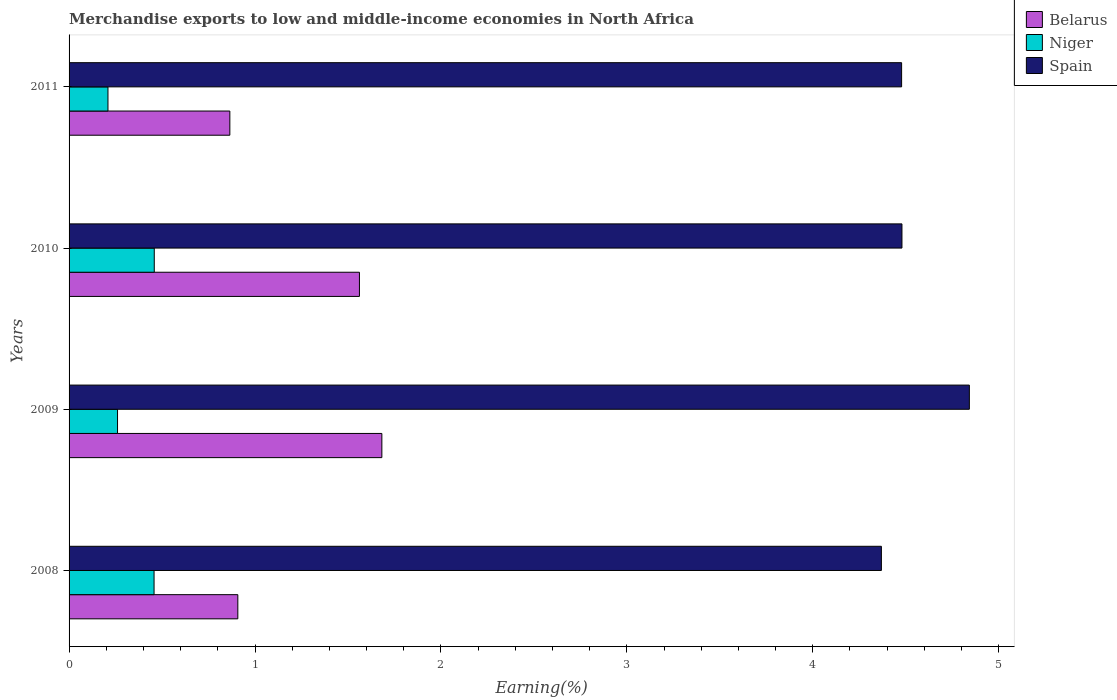How many different coloured bars are there?
Give a very brief answer. 3. How many groups of bars are there?
Offer a terse response. 4. Are the number of bars per tick equal to the number of legend labels?
Ensure brevity in your answer.  Yes. How many bars are there on the 4th tick from the top?
Offer a terse response. 3. How many bars are there on the 2nd tick from the bottom?
Offer a terse response. 3. What is the label of the 3rd group of bars from the top?
Make the answer very short. 2009. In how many cases, is the number of bars for a given year not equal to the number of legend labels?
Offer a terse response. 0. What is the percentage of amount earned from merchandise exports in Belarus in 2010?
Offer a very short reply. 1.56. Across all years, what is the maximum percentage of amount earned from merchandise exports in Niger?
Offer a very short reply. 0.46. Across all years, what is the minimum percentage of amount earned from merchandise exports in Belarus?
Keep it short and to the point. 0.86. In which year was the percentage of amount earned from merchandise exports in Belarus minimum?
Your answer should be compact. 2011. What is the total percentage of amount earned from merchandise exports in Spain in the graph?
Offer a terse response. 18.17. What is the difference between the percentage of amount earned from merchandise exports in Belarus in 2009 and that in 2011?
Make the answer very short. 0.82. What is the difference between the percentage of amount earned from merchandise exports in Spain in 2010 and the percentage of amount earned from merchandise exports in Belarus in 2008?
Offer a very short reply. 3.57. What is the average percentage of amount earned from merchandise exports in Belarus per year?
Make the answer very short. 1.25. In the year 2011, what is the difference between the percentage of amount earned from merchandise exports in Belarus and percentage of amount earned from merchandise exports in Spain?
Ensure brevity in your answer.  -3.61. In how many years, is the percentage of amount earned from merchandise exports in Belarus greater than 1.4 %?
Your answer should be very brief. 2. What is the ratio of the percentage of amount earned from merchandise exports in Niger in 2009 to that in 2010?
Keep it short and to the point. 0.57. What is the difference between the highest and the second highest percentage of amount earned from merchandise exports in Belarus?
Offer a terse response. 0.12. What is the difference between the highest and the lowest percentage of amount earned from merchandise exports in Belarus?
Keep it short and to the point. 0.82. In how many years, is the percentage of amount earned from merchandise exports in Spain greater than the average percentage of amount earned from merchandise exports in Spain taken over all years?
Your answer should be very brief. 1. What does the 1st bar from the bottom in 2009 represents?
Provide a succinct answer. Belarus. How many bars are there?
Provide a short and direct response. 12. What is the difference between two consecutive major ticks on the X-axis?
Ensure brevity in your answer.  1. Are the values on the major ticks of X-axis written in scientific E-notation?
Provide a short and direct response. No. Does the graph contain any zero values?
Your answer should be compact. No. Where does the legend appear in the graph?
Your answer should be compact. Top right. How are the legend labels stacked?
Your answer should be very brief. Vertical. What is the title of the graph?
Keep it short and to the point. Merchandise exports to low and middle-income economies in North Africa. What is the label or title of the X-axis?
Provide a short and direct response. Earning(%). What is the label or title of the Y-axis?
Provide a succinct answer. Years. What is the Earning(%) in Belarus in 2008?
Your answer should be very brief. 0.91. What is the Earning(%) in Niger in 2008?
Provide a short and direct response. 0.46. What is the Earning(%) in Spain in 2008?
Offer a terse response. 4.37. What is the Earning(%) in Belarus in 2009?
Offer a terse response. 1.68. What is the Earning(%) of Niger in 2009?
Provide a succinct answer. 0.26. What is the Earning(%) of Spain in 2009?
Give a very brief answer. 4.84. What is the Earning(%) in Belarus in 2010?
Ensure brevity in your answer.  1.56. What is the Earning(%) in Niger in 2010?
Your answer should be compact. 0.46. What is the Earning(%) of Spain in 2010?
Your answer should be very brief. 4.48. What is the Earning(%) of Belarus in 2011?
Make the answer very short. 0.86. What is the Earning(%) in Niger in 2011?
Provide a succinct answer. 0.21. What is the Earning(%) in Spain in 2011?
Your response must be concise. 4.48. Across all years, what is the maximum Earning(%) of Belarus?
Give a very brief answer. 1.68. Across all years, what is the maximum Earning(%) in Niger?
Your answer should be compact. 0.46. Across all years, what is the maximum Earning(%) of Spain?
Give a very brief answer. 4.84. Across all years, what is the minimum Earning(%) of Belarus?
Make the answer very short. 0.86. Across all years, what is the minimum Earning(%) in Niger?
Provide a succinct answer. 0.21. Across all years, what is the minimum Earning(%) of Spain?
Provide a succinct answer. 4.37. What is the total Earning(%) of Belarus in the graph?
Your response must be concise. 5.02. What is the total Earning(%) in Niger in the graph?
Give a very brief answer. 1.39. What is the total Earning(%) in Spain in the graph?
Give a very brief answer. 18.17. What is the difference between the Earning(%) of Belarus in 2008 and that in 2009?
Offer a terse response. -0.77. What is the difference between the Earning(%) of Niger in 2008 and that in 2009?
Offer a terse response. 0.2. What is the difference between the Earning(%) in Spain in 2008 and that in 2009?
Give a very brief answer. -0.47. What is the difference between the Earning(%) of Belarus in 2008 and that in 2010?
Give a very brief answer. -0.65. What is the difference between the Earning(%) in Niger in 2008 and that in 2010?
Your answer should be compact. -0. What is the difference between the Earning(%) in Spain in 2008 and that in 2010?
Your response must be concise. -0.11. What is the difference between the Earning(%) in Belarus in 2008 and that in 2011?
Provide a succinct answer. 0.04. What is the difference between the Earning(%) of Niger in 2008 and that in 2011?
Offer a terse response. 0.25. What is the difference between the Earning(%) of Spain in 2008 and that in 2011?
Your answer should be very brief. -0.11. What is the difference between the Earning(%) of Belarus in 2009 and that in 2010?
Your answer should be very brief. 0.12. What is the difference between the Earning(%) in Niger in 2009 and that in 2010?
Provide a succinct answer. -0.2. What is the difference between the Earning(%) in Spain in 2009 and that in 2010?
Make the answer very short. 0.36. What is the difference between the Earning(%) in Belarus in 2009 and that in 2011?
Offer a terse response. 0.82. What is the difference between the Earning(%) of Niger in 2009 and that in 2011?
Ensure brevity in your answer.  0.05. What is the difference between the Earning(%) in Spain in 2009 and that in 2011?
Your answer should be very brief. 0.36. What is the difference between the Earning(%) in Belarus in 2010 and that in 2011?
Your answer should be very brief. 0.7. What is the difference between the Earning(%) of Niger in 2010 and that in 2011?
Your answer should be very brief. 0.25. What is the difference between the Earning(%) of Spain in 2010 and that in 2011?
Your answer should be very brief. 0. What is the difference between the Earning(%) of Belarus in 2008 and the Earning(%) of Niger in 2009?
Keep it short and to the point. 0.65. What is the difference between the Earning(%) of Belarus in 2008 and the Earning(%) of Spain in 2009?
Your answer should be compact. -3.93. What is the difference between the Earning(%) in Niger in 2008 and the Earning(%) in Spain in 2009?
Your response must be concise. -4.39. What is the difference between the Earning(%) of Belarus in 2008 and the Earning(%) of Niger in 2010?
Offer a very short reply. 0.45. What is the difference between the Earning(%) in Belarus in 2008 and the Earning(%) in Spain in 2010?
Give a very brief answer. -3.57. What is the difference between the Earning(%) of Niger in 2008 and the Earning(%) of Spain in 2010?
Make the answer very short. -4.02. What is the difference between the Earning(%) of Belarus in 2008 and the Earning(%) of Niger in 2011?
Provide a short and direct response. 0.7. What is the difference between the Earning(%) in Belarus in 2008 and the Earning(%) in Spain in 2011?
Provide a succinct answer. -3.57. What is the difference between the Earning(%) in Niger in 2008 and the Earning(%) in Spain in 2011?
Offer a very short reply. -4.02. What is the difference between the Earning(%) of Belarus in 2009 and the Earning(%) of Niger in 2010?
Give a very brief answer. 1.22. What is the difference between the Earning(%) in Belarus in 2009 and the Earning(%) in Spain in 2010?
Keep it short and to the point. -2.8. What is the difference between the Earning(%) of Niger in 2009 and the Earning(%) of Spain in 2010?
Provide a succinct answer. -4.22. What is the difference between the Earning(%) in Belarus in 2009 and the Earning(%) in Niger in 2011?
Make the answer very short. 1.47. What is the difference between the Earning(%) of Belarus in 2009 and the Earning(%) of Spain in 2011?
Make the answer very short. -2.8. What is the difference between the Earning(%) in Niger in 2009 and the Earning(%) in Spain in 2011?
Keep it short and to the point. -4.22. What is the difference between the Earning(%) in Belarus in 2010 and the Earning(%) in Niger in 2011?
Offer a terse response. 1.35. What is the difference between the Earning(%) in Belarus in 2010 and the Earning(%) in Spain in 2011?
Ensure brevity in your answer.  -2.92. What is the difference between the Earning(%) of Niger in 2010 and the Earning(%) of Spain in 2011?
Provide a succinct answer. -4.02. What is the average Earning(%) in Belarus per year?
Your answer should be compact. 1.25. What is the average Earning(%) of Niger per year?
Keep it short and to the point. 0.35. What is the average Earning(%) in Spain per year?
Your answer should be very brief. 4.54. In the year 2008, what is the difference between the Earning(%) of Belarus and Earning(%) of Niger?
Provide a short and direct response. 0.45. In the year 2008, what is the difference between the Earning(%) of Belarus and Earning(%) of Spain?
Your answer should be very brief. -3.46. In the year 2008, what is the difference between the Earning(%) of Niger and Earning(%) of Spain?
Your answer should be compact. -3.91. In the year 2009, what is the difference between the Earning(%) of Belarus and Earning(%) of Niger?
Your response must be concise. 1.42. In the year 2009, what is the difference between the Earning(%) of Belarus and Earning(%) of Spain?
Offer a very short reply. -3.16. In the year 2009, what is the difference between the Earning(%) in Niger and Earning(%) in Spain?
Your answer should be very brief. -4.58. In the year 2010, what is the difference between the Earning(%) in Belarus and Earning(%) in Niger?
Provide a short and direct response. 1.1. In the year 2010, what is the difference between the Earning(%) in Belarus and Earning(%) in Spain?
Provide a short and direct response. -2.92. In the year 2010, what is the difference between the Earning(%) in Niger and Earning(%) in Spain?
Make the answer very short. -4.02. In the year 2011, what is the difference between the Earning(%) of Belarus and Earning(%) of Niger?
Ensure brevity in your answer.  0.66. In the year 2011, what is the difference between the Earning(%) in Belarus and Earning(%) in Spain?
Provide a short and direct response. -3.61. In the year 2011, what is the difference between the Earning(%) of Niger and Earning(%) of Spain?
Offer a very short reply. -4.27. What is the ratio of the Earning(%) in Belarus in 2008 to that in 2009?
Offer a terse response. 0.54. What is the ratio of the Earning(%) of Niger in 2008 to that in 2009?
Offer a terse response. 1.75. What is the ratio of the Earning(%) in Spain in 2008 to that in 2009?
Provide a short and direct response. 0.9. What is the ratio of the Earning(%) of Belarus in 2008 to that in 2010?
Your response must be concise. 0.58. What is the ratio of the Earning(%) of Spain in 2008 to that in 2010?
Your response must be concise. 0.98. What is the ratio of the Earning(%) in Belarus in 2008 to that in 2011?
Your response must be concise. 1.05. What is the ratio of the Earning(%) of Niger in 2008 to that in 2011?
Give a very brief answer. 2.19. What is the ratio of the Earning(%) in Spain in 2008 to that in 2011?
Offer a very short reply. 0.98. What is the ratio of the Earning(%) of Belarus in 2009 to that in 2010?
Make the answer very short. 1.08. What is the ratio of the Earning(%) of Niger in 2009 to that in 2010?
Give a very brief answer. 0.57. What is the ratio of the Earning(%) in Spain in 2009 to that in 2010?
Give a very brief answer. 1.08. What is the ratio of the Earning(%) in Belarus in 2009 to that in 2011?
Give a very brief answer. 1.95. What is the ratio of the Earning(%) in Niger in 2009 to that in 2011?
Your answer should be very brief. 1.25. What is the ratio of the Earning(%) in Spain in 2009 to that in 2011?
Your answer should be very brief. 1.08. What is the ratio of the Earning(%) in Belarus in 2010 to that in 2011?
Your response must be concise. 1.81. What is the ratio of the Earning(%) in Niger in 2010 to that in 2011?
Provide a succinct answer. 2.19. What is the difference between the highest and the second highest Earning(%) in Belarus?
Your answer should be very brief. 0.12. What is the difference between the highest and the second highest Earning(%) of Niger?
Keep it short and to the point. 0. What is the difference between the highest and the second highest Earning(%) in Spain?
Provide a succinct answer. 0.36. What is the difference between the highest and the lowest Earning(%) in Belarus?
Offer a terse response. 0.82. What is the difference between the highest and the lowest Earning(%) in Niger?
Your response must be concise. 0.25. What is the difference between the highest and the lowest Earning(%) in Spain?
Offer a very short reply. 0.47. 